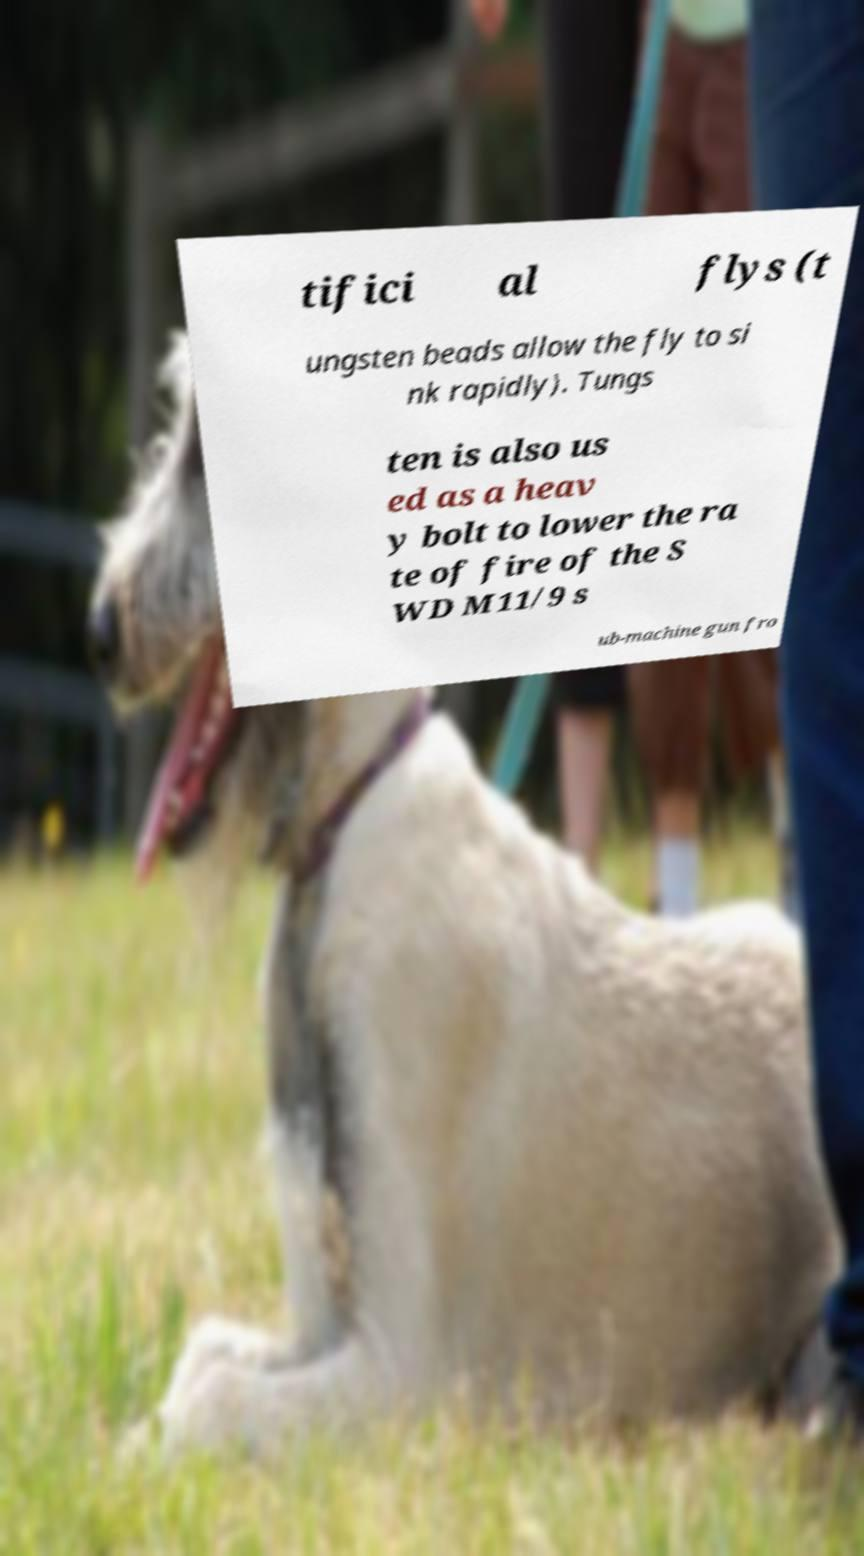Please identify and transcribe the text found in this image. tifici al flys (t ungsten beads allow the fly to si nk rapidly). Tungs ten is also us ed as a heav y bolt to lower the ra te of fire of the S WD M11/9 s ub-machine gun fro 